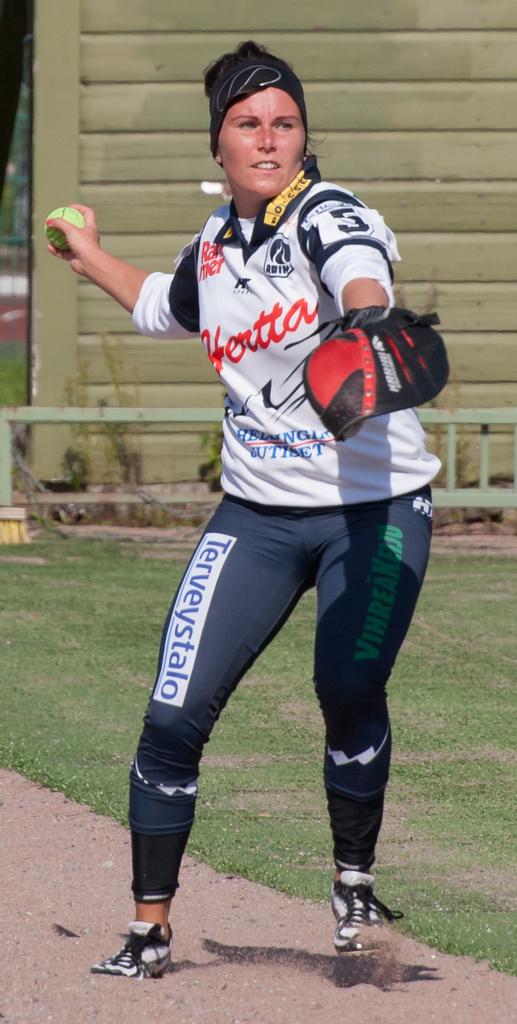What is the orange word on her shirt?
Ensure brevity in your answer.  Hertta. 